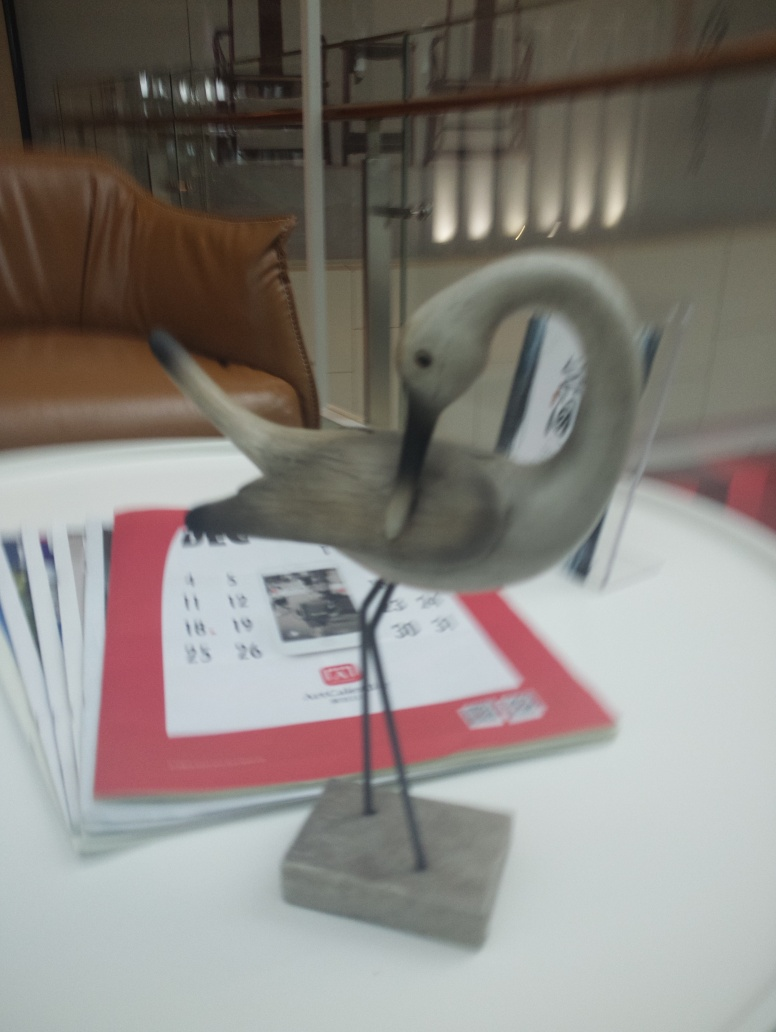What kind of object is in the foreground of this image? The object in the foreground appears to be a sculptural representation of a bird, possibly a swan, given its elongated neck and curved beak. It sits atop a base, suggesting it is a decorative piece, possibly made of materials such as metal or stone. 